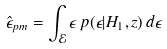<formula> <loc_0><loc_0><loc_500><loc_500>\hat { \epsilon } _ { p m } = \int _ { \mathcal { E } } \epsilon \, p ( \epsilon | H _ { 1 } , z ) \, d \epsilon</formula> 